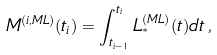Convert formula to latex. <formula><loc_0><loc_0><loc_500><loc_500>M ^ { ( i , M L ) } ( t _ { i } ) = \int _ { t _ { i - 1 } } ^ { t _ { i } } L _ { ^ { * } } ^ { ( M L ) } ( t ) d t \, ,</formula> 